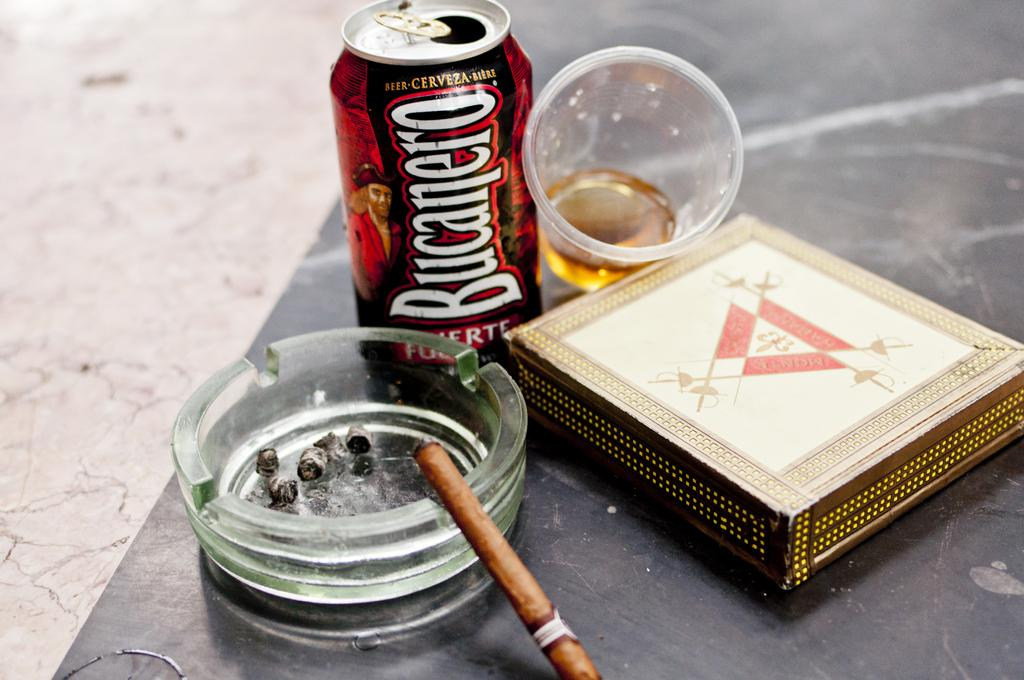<image>
Describe the image concisely. A can of Bucanero sits on a table next to an ash tray. 